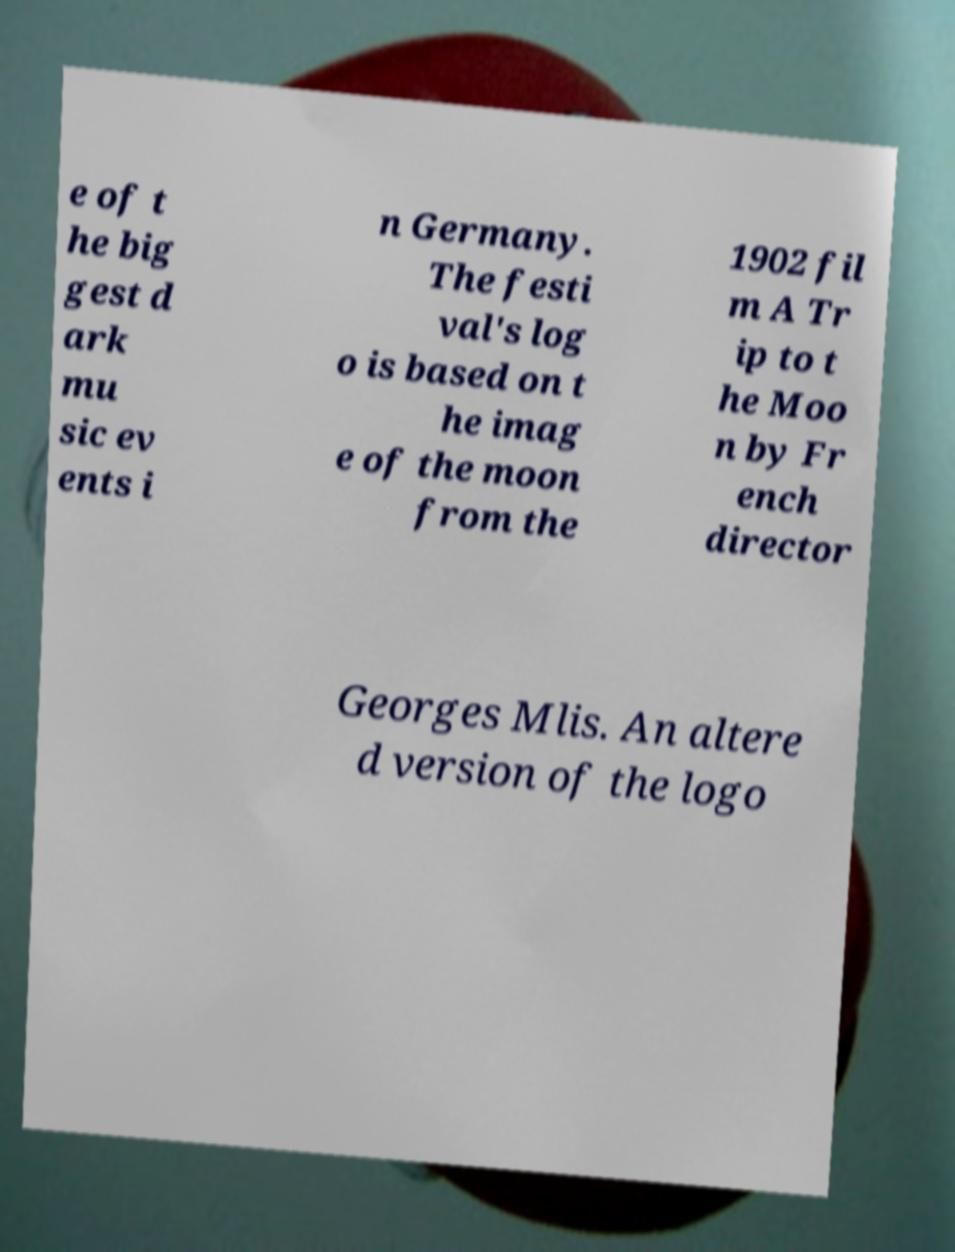Please read and relay the text visible in this image. What does it say? e of t he big gest d ark mu sic ev ents i n Germany. The festi val's log o is based on t he imag e of the moon from the 1902 fil m A Tr ip to t he Moo n by Fr ench director Georges Mlis. An altere d version of the logo 